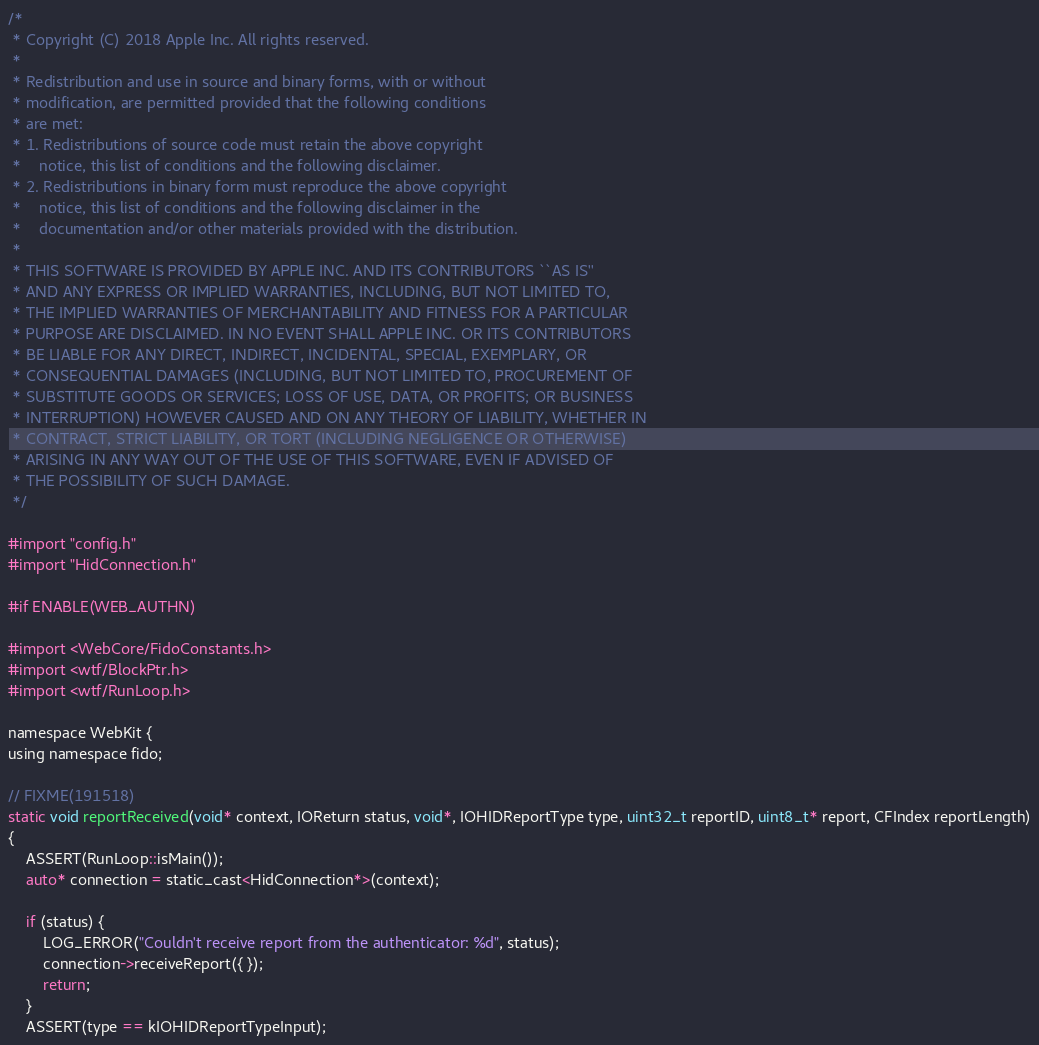Convert code to text. <code><loc_0><loc_0><loc_500><loc_500><_ObjectiveC_>/*
 * Copyright (C) 2018 Apple Inc. All rights reserved.
 *
 * Redistribution and use in source and binary forms, with or without
 * modification, are permitted provided that the following conditions
 * are met:
 * 1. Redistributions of source code must retain the above copyright
 *    notice, this list of conditions and the following disclaimer.
 * 2. Redistributions in binary form must reproduce the above copyright
 *    notice, this list of conditions and the following disclaimer in the
 *    documentation and/or other materials provided with the distribution.
 *
 * THIS SOFTWARE IS PROVIDED BY APPLE INC. AND ITS CONTRIBUTORS ``AS IS''
 * AND ANY EXPRESS OR IMPLIED WARRANTIES, INCLUDING, BUT NOT LIMITED TO,
 * THE IMPLIED WARRANTIES OF MERCHANTABILITY AND FITNESS FOR A PARTICULAR
 * PURPOSE ARE DISCLAIMED. IN NO EVENT SHALL APPLE INC. OR ITS CONTRIBUTORS
 * BE LIABLE FOR ANY DIRECT, INDIRECT, INCIDENTAL, SPECIAL, EXEMPLARY, OR
 * CONSEQUENTIAL DAMAGES (INCLUDING, BUT NOT LIMITED TO, PROCUREMENT OF
 * SUBSTITUTE GOODS OR SERVICES; LOSS OF USE, DATA, OR PROFITS; OR BUSINESS
 * INTERRUPTION) HOWEVER CAUSED AND ON ANY THEORY OF LIABILITY, WHETHER IN
 * CONTRACT, STRICT LIABILITY, OR TORT (INCLUDING NEGLIGENCE OR OTHERWISE)
 * ARISING IN ANY WAY OUT OF THE USE OF THIS SOFTWARE, EVEN IF ADVISED OF
 * THE POSSIBILITY OF SUCH DAMAGE.
 */

#import "config.h"
#import "HidConnection.h"

#if ENABLE(WEB_AUTHN)

#import <WebCore/FidoConstants.h>
#import <wtf/BlockPtr.h>
#import <wtf/RunLoop.h>

namespace WebKit {
using namespace fido;

// FIXME(191518)
static void reportReceived(void* context, IOReturn status, void*, IOHIDReportType type, uint32_t reportID, uint8_t* report, CFIndex reportLength)
{
    ASSERT(RunLoop::isMain());
    auto* connection = static_cast<HidConnection*>(context);

    if (status) {
        LOG_ERROR("Couldn't receive report from the authenticator: %d", status);
        connection->receiveReport({ });
        return;
    }
    ASSERT(type == kIOHIDReportTypeInput);</code> 